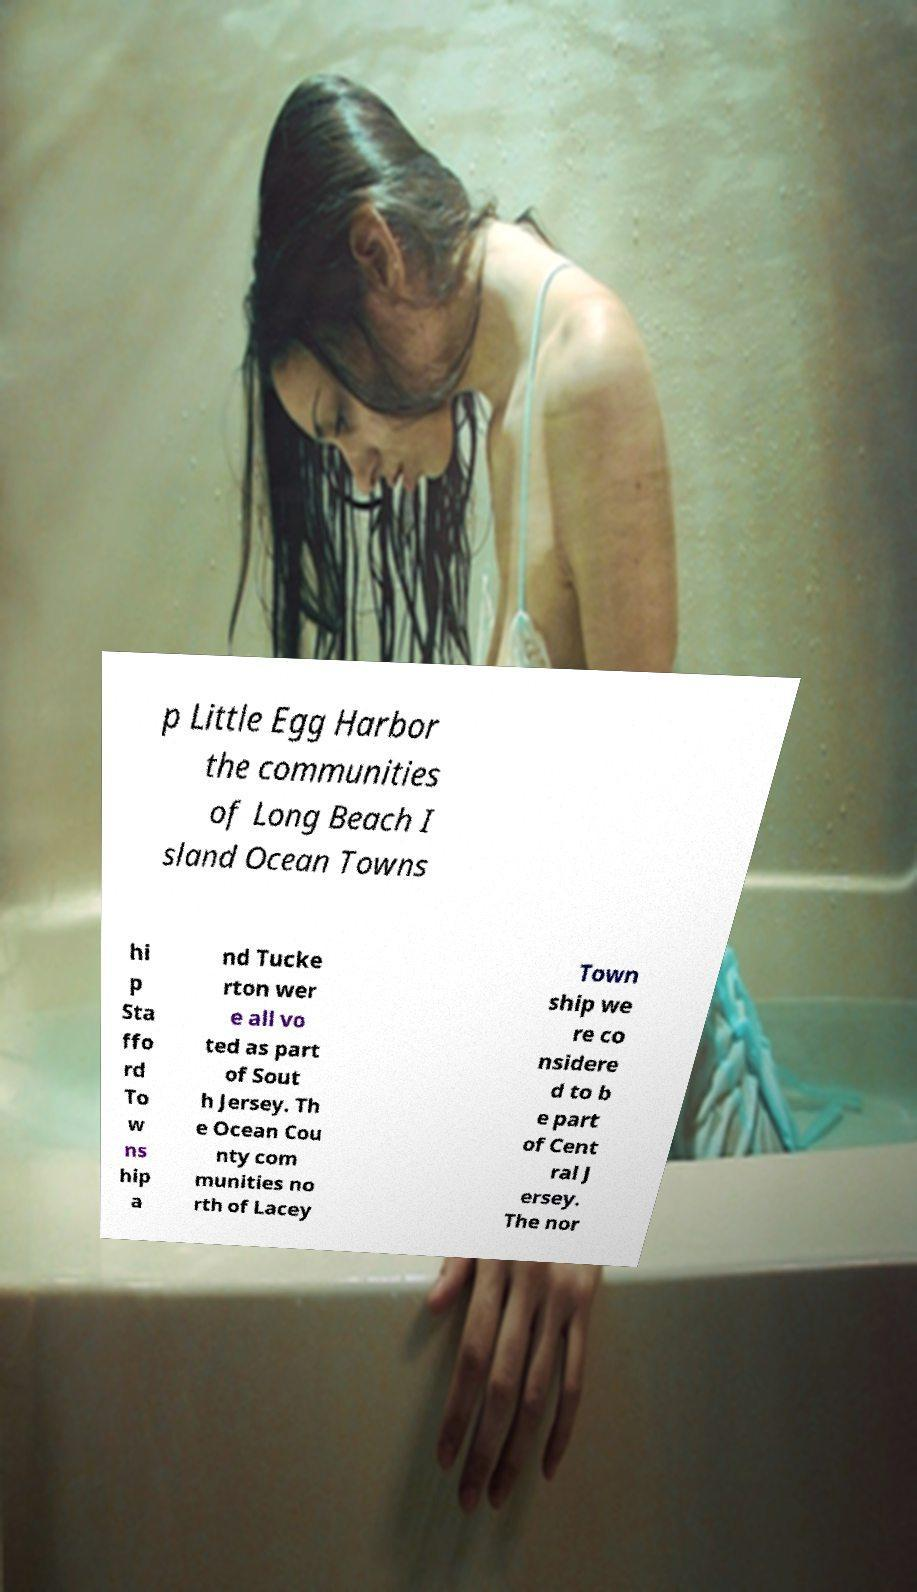Can you read and provide the text displayed in the image?This photo seems to have some interesting text. Can you extract and type it out for me? p Little Egg Harbor the communities of Long Beach I sland Ocean Towns hi p Sta ffo rd To w ns hip a nd Tucke rton wer e all vo ted as part of Sout h Jersey. Th e Ocean Cou nty com munities no rth of Lacey Town ship we re co nsidere d to b e part of Cent ral J ersey. The nor 